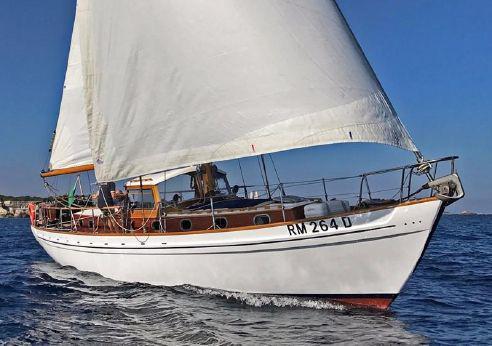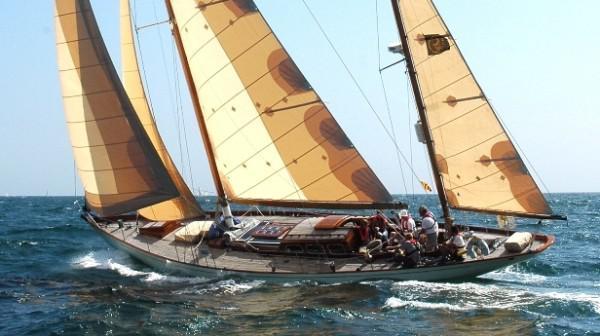The first image is the image on the left, the second image is the image on the right. Evaluate the accuracy of this statement regarding the images: "A sailboat with three white sails is tilted sideways towards the water.". Is it true? Answer yes or no. No. 